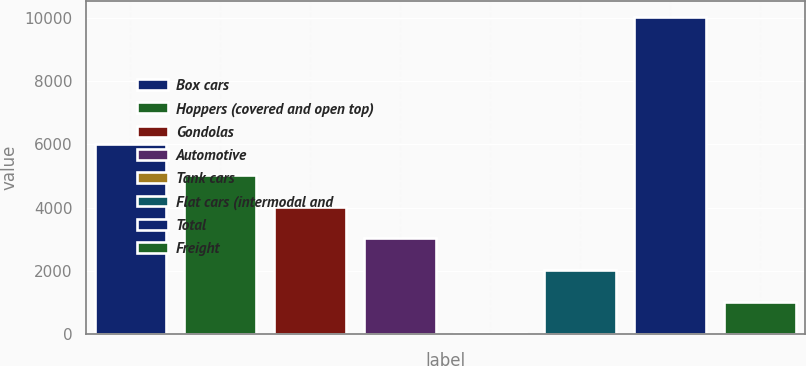Convert chart to OTSL. <chart><loc_0><loc_0><loc_500><loc_500><bar_chart><fcel>Box cars<fcel>Hoppers (covered and open top)<fcel>Gondolas<fcel>Automotive<fcel>Tank cars<fcel>Flat cars (intermodal and<fcel>Total<fcel>Freight<nl><fcel>6030.6<fcel>5028<fcel>4025.4<fcel>3022.8<fcel>15<fcel>2020.2<fcel>10041<fcel>1017.6<nl></chart> 